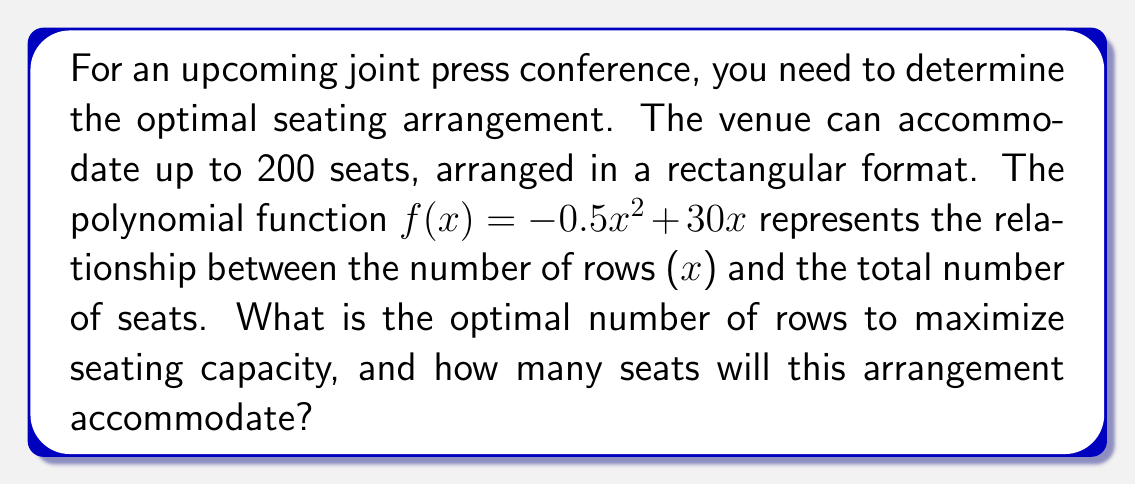Give your solution to this math problem. To solve this problem, we'll follow these steps:

1) The function $f(x) = -0.5x^2 + 30x$ represents the total number of seats, where $x$ is the number of rows.

2) To find the maximum value of this quadratic function, we need to find the vertex. For a quadratic function in the form $f(x) = ax^2 + bx + c$, the x-coordinate of the vertex is given by $x = -\frac{b}{2a}$.

3) In our case, $a = -0.5$ and $b = 30$. So:

   $x = -\frac{30}{2(-0.5)} = -\frac{30}{-1} = 30$

4) This means that the optimal number of rows is 30.

5) To find the maximum number of seats, we substitute $x = 30$ into our original function:

   $f(30) = -0.5(30)^2 + 30(30)$
   $= -0.5(900) + 900$
   $= -450 + 900$
   $= 450$

6) Therefore, the maximum number of seats is 450.

7) However, the question states that the venue can accommodate up to 200 seats. Since our calculated maximum exceeds this, we'll use the venue's maximum of 200 seats.
Answer: 30 rows, 200 seats 